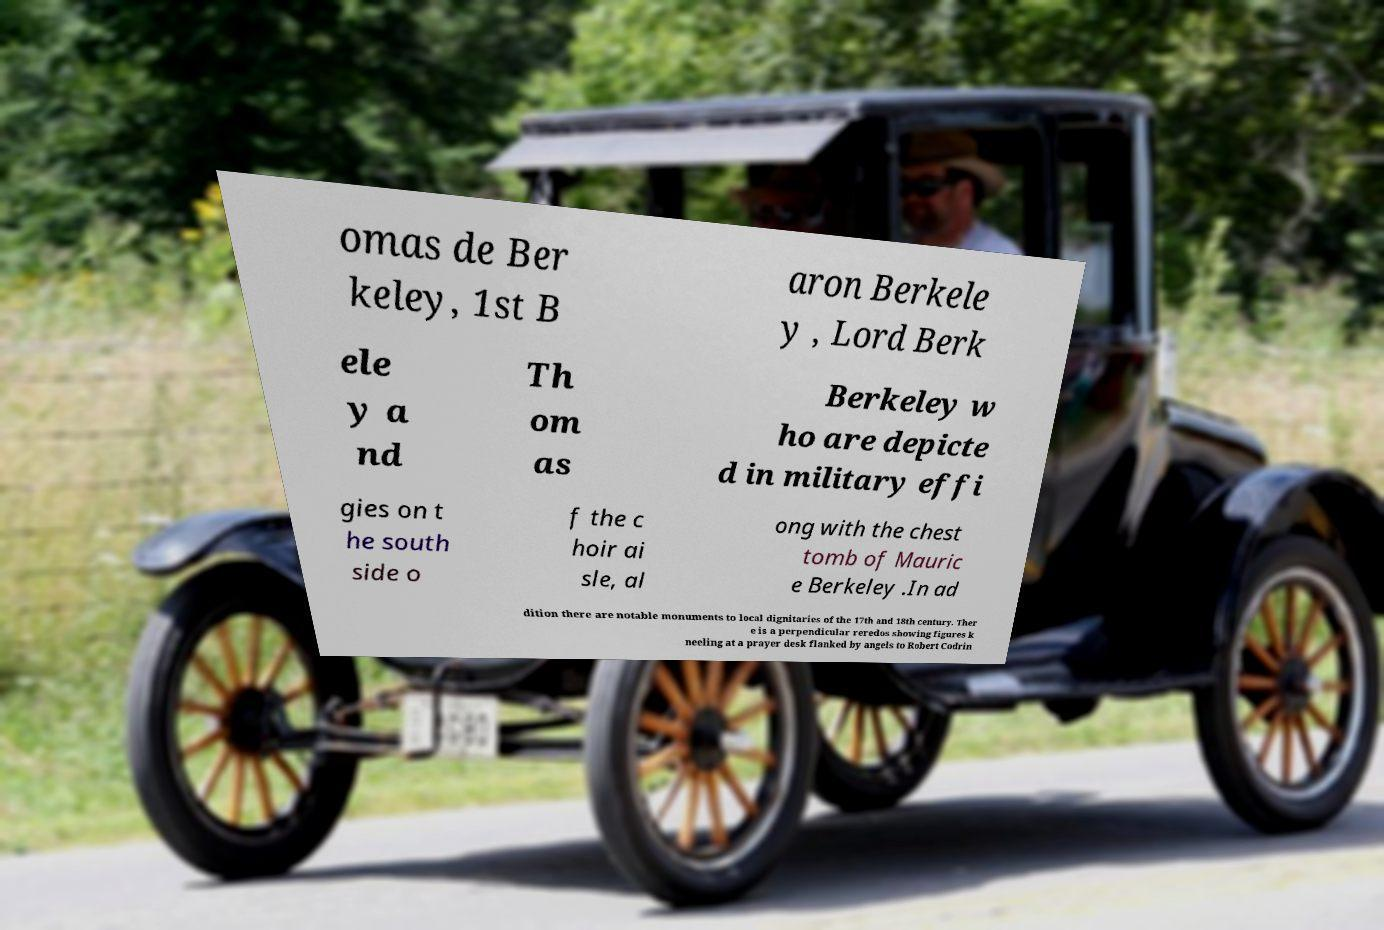Could you extract and type out the text from this image? omas de Ber keley, 1st B aron Berkele y , Lord Berk ele y a nd Th om as Berkeley w ho are depicte d in military effi gies on t he south side o f the c hoir ai sle, al ong with the chest tomb of Mauric e Berkeley .In ad dition there are notable monuments to local dignitaries of the 17th and 18th century. Ther e is a perpendicular reredos showing figures k neeling at a prayer desk flanked by angels to Robert Codrin 